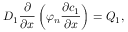Convert formula to latex. <formula><loc_0><loc_0><loc_500><loc_500>D _ { 1 } \frac { \partial } { \partial x } \left ( \varphi _ { n } \frac { \partial c _ { 1 } } { \partial x } \right ) = Q _ { 1 } ,</formula> 